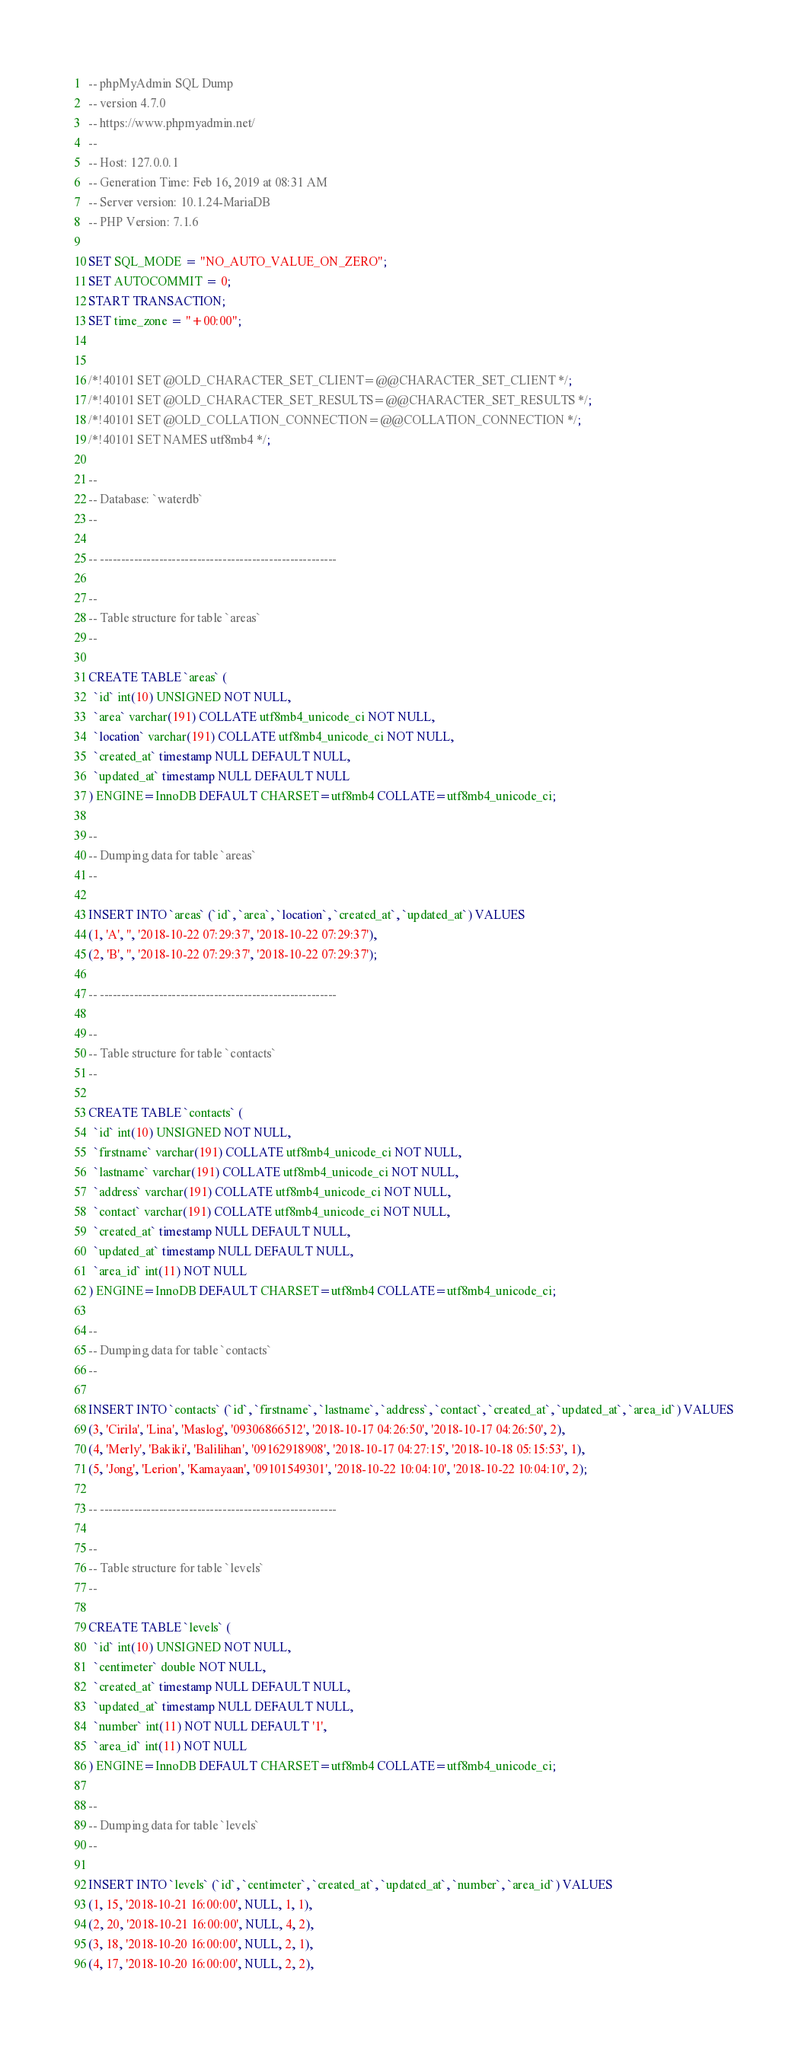<code> <loc_0><loc_0><loc_500><loc_500><_SQL_>-- phpMyAdmin SQL Dump
-- version 4.7.0
-- https://www.phpmyadmin.net/
--
-- Host: 127.0.0.1
-- Generation Time: Feb 16, 2019 at 08:31 AM
-- Server version: 10.1.24-MariaDB
-- PHP Version: 7.1.6

SET SQL_MODE = "NO_AUTO_VALUE_ON_ZERO";
SET AUTOCOMMIT = 0;
START TRANSACTION;
SET time_zone = "+00:00";


/*!40101 SET @OLD_CHARACTER_SET_CLIENT=@@CHARACTER_SET_CLIENT */;
/*!40101 SET @OLD_CHARACTER_SET_RESULTS=@@CHARACTER_SET_RESULTS */;
/*!40101 SET @OLD_COLLATION_CONNECTION=@@COLLATION_CONNECTION */;
/*!40101 SET NAMES utf8mb4 */;

--
-- Database: `waterdb`
--

-- --------------------------------------------------------

--
-- Table structure for table `areas`
--

CREATE TABLE `areas` (
  `id` int(10) UNSIGNED NOT NULL,
  `area` varchar(191) COLLATE utf8mb4_unicode_ci NOT NULL,
  `location` varchar(191) COLLATE utf8mb4_unicode_ci NOT NULL,
  `created_at` timestamp NULL DEFAULT NULL,
  `updated_at` timestamp NULL DEFAULT NULL
) ENGINE=InnoDB DEFAULT CHARSET=utf8mb4 COLLATE=utf8mb4_unicode_ci;

--
-- Dumping data for table `areas`
--

INSERT INTO `areas` (`id`, `area`, `location`, `created_at`, `updated_at`) VALUES
(1, 'A', '', '2018-10-22 07:29:37', '2018-10-22 07:29:37'),
(2, 'B', '', '2018-10-22 07:29:37', '2018-10-22 07:29:37');

-- --------------------------------------------------------

--
-- Table structure for table `contacts`
--

CREATE TABLE `contacts` (
  `id` int(10) UNSIGNED NOT NULL,
  `firstname` varchar(191) COLLATE utf8mb4_unicode_ci NOT NULL,
  `lastname` varchar(191) COLLATE utf8mb4_unicode_ci NOT NULL,
  `address` varchar(191) COLLATE utf8mb4_unicode_ci NOT NULL,
  `contact` varchar(191) COLLATE utf8mb4_unicode_ci NOT NULL,
  `created_at` timestamp NULL DEFAULT NULL,
  `updated_at` timestamp NULL DEFAULT NULL,
  `area_id` int(11) NOT NULL
) ENGINE=InnoDB DEFAULT CHARSET=utf8mb4 COLLATE=utf8mb4_unicode_ci;

--
-- Dumping data for table `contacts`
--

INSERT INTO `contacts` (`id`, `firstname`, `lastname`, `address`, `contact`, `created_at`, `updated_at`, `area_id`) VALUES
(3, 'Cirila', 'Lina', 'Maslog', '09306866512', '2018-10-17 04:26:50', '2018-10-17 04:26:50', 2),
(4, 'Merly', 'Bakiki', 'Balilihan', '09162918908', '2018-10-17 04:27:15', '2018-10-18 05:15:53', 1),
(5, 'Jong', 'Lerion', 'Kamayaan', '09101549301', '2018-10-22 10:04:10', '2018-10-22 10:04:10', 2);

-- --------------------------------------------------------

--
-- Table structure for table `levels`
--

CREATE TABLE `levels` (
  `id` int(10) UNSIGNED NOT NULL,
  `centimeter` double NOT NULL,
  `created_at` timestamp NULL DEFAULT NULL,
  `updated_at` timestamp NULL DEFAULT NULL,
  `number` int(11) NOT NULL DEFAULT '1',
  `area_id` int(11) NOT NULL
) ENGINE=InnoDB DEFAULT CHARSET=utf8mb4 COLLATE=utf8mb4_unicode_ci;

--
-- Dumping data for table `levels`
--

INSERT INTO `levels` (`id`, `centimeter`, `created_at`, `updated_at`, `number`, `area_id`) VALUES
(1, 15, '2018-10-21 16:00:00', NULL, 1, 1),
(2, 20, '2018-10-21 16:00:00', NULL, 4, 2),
(3, 18, '2018-10-20 16:00:00', NULL, 2, 1),
(4, 17, '2018-10-20 16:00:00', NULL, 2, 2),</code> 